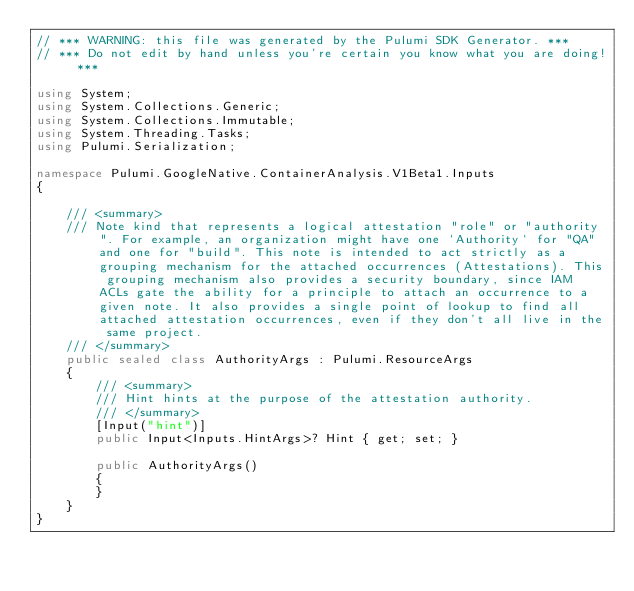<code> <loc_0><loc_0><loc_500><loc_500><_C#_>// *** WARNING: this file was generated by the Pulumi SDK Generator. ***
// *** Do not edit by hand unless you're certain you know what you are doing! ***

using System;
using System.Collections.Generic;
using System.Collections.Immutable;
using System.Threading.Tasks;
using Pulumi.Serialization;

namespace Pulumi.GoogleNative.ContainerAnalysis.V1Beta1.Inputs
{

    /// <summary>
    /// Note kind that represents a logical attestation "role" or "authority". For example, an organization might have one `Authority` for "QA" and one for "build". This note is intended to act strictly as a grouping mechanism for the attached occurrences (Attestations). This grouping mechanism also provides a security boundary, since IAM ACLs gate the ability for a principle to attach an occurrence to a given note. It also provides a single point of lookup to find all attached attestation occurrences, even if they don't all live in the same project.
    /// </summary>
    public sealed class AuthorityArgs : Pulumi.ResourceArgs
    {
        /// <summary>
        /// Hint hints at the purpose of the attestation authority.
        /// </summary>
        [Input("hint")]
        public Input<Inputs.HintArgs>? Hint { get; set; }

        public AuthorityArgs()
        {
        }
    }
}
</code> 